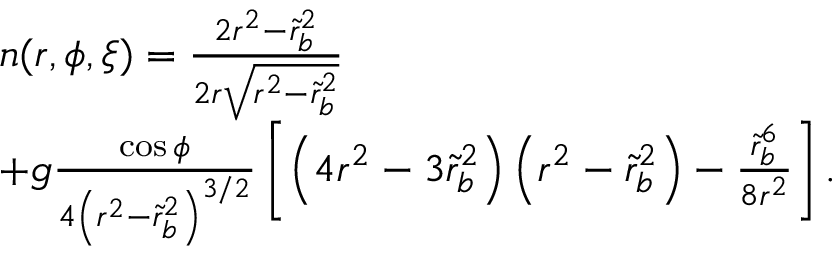Convert formula to latex. <formula><loc_0><loc_0><loc_500><loc_500>\begin{array} { r l } & { n ( r , \phi , \xi ) = \frac { 2 r ^ { 2 } - \tilde { r } _ { b } ^ { 2 } } { 2 r \sqrt { r ^ { 2 } - \tilde { r } _ { b } ^ { 2 } } } } \\ & { + g \frac { \cos \phi } { 4 \left ( r ^ { 2 } - \tilde { r } _ { b } ^ { 2 } \right ) ^ { 3 / 2 } } \left [ \left ( 4 r ^ { 2 } - 3 \tilde { r } _ { b } ^ { 2 } \right ) \left ( r ^ { 2 } - \tilde { r } _ { b } ^ { 2 } \right ) - \frac { \tilde { r } _ { b } ^ { 6 } } { 8 r ^ { 2 } } \right ] . } \end{array}</formula> 